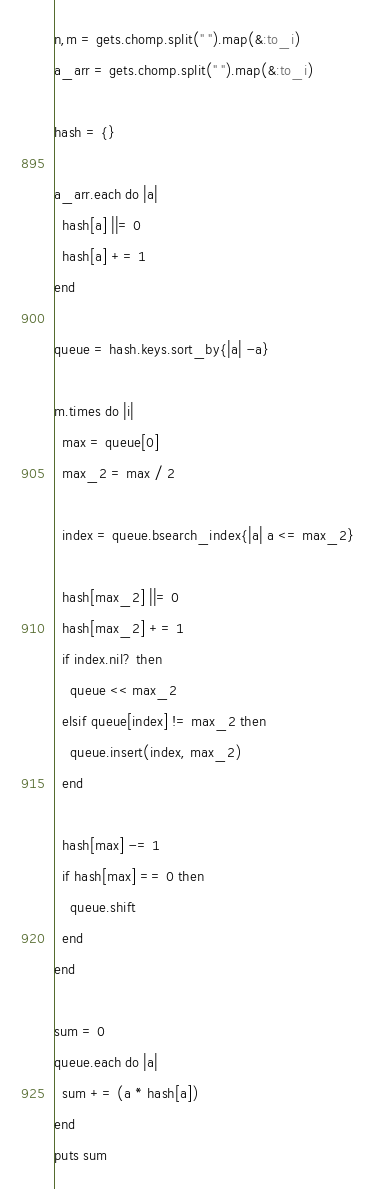<code> <loc_0><loc_0><loc_500><loc_500><_Ruby_>n,m = gets.chomp.split(" ").map(&:to_i)
a_arr = gets.chomp.split(" ").map(&:to_i)

hash = {}

a_arr.each do |a|
  hash[a] ||= 0
  hash[a] += 1
end

queue = hash.keys.sort_by{|a| -a}

m.times do |i|
  max = queue[0]
  max_2 = max / 2

  index = queue.bsearch_index{|a| a <= max_2}

  hash[max_2] ||= 0
  hash[max_2] += 1
  if index.nil? then
    queue << max_2
  elsif queue[index] != max_2 then
    queue.insert(index, max_2)
  end

  hash[max] -= 1
  if hash[max] == 0 then
    queue.shift
  end
end

sum = 0
queue.each do |a|
  sum += (a * hash[a])
end
puts sum
</code> 